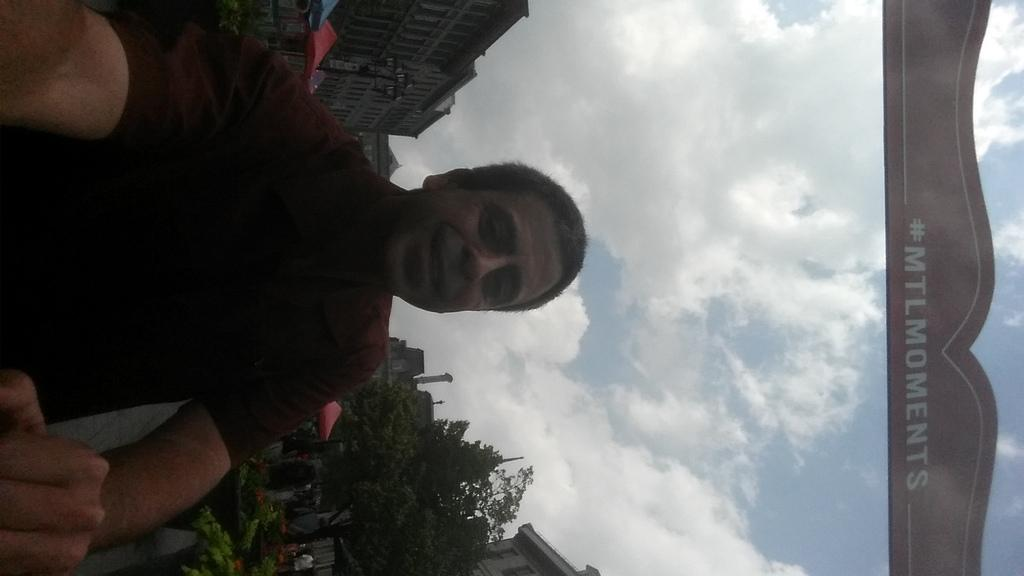Who or what is the main subject in the image? There is a person in the image. What can be seen in the background of the image? There is a market, people, buildings, and trees visible in the background of the image. How does the person in the image show respect to the trees? The image does not show the person interacting with the trees or demonstrating respect in any way. 